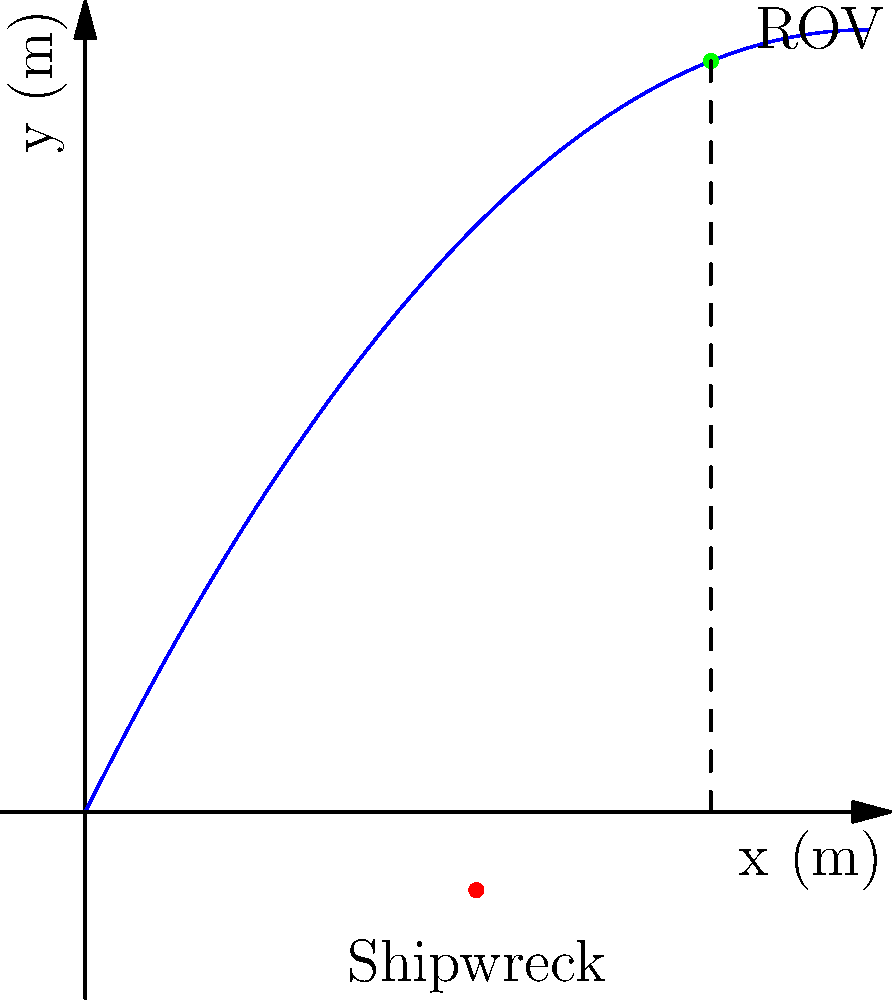An ROV is deployed to investigate a medieval shipwreck site. The ROV's trajectory follows the parabolic path given by the equation $y = -0.02x^2 + 2x$, where $x$ and $y$ are measured in meters. The shipwreck is located at coordinates (25, -5). At what horizontal distance from its starting point will the ROV be directly above the shipwreck? To solve this problem, we need to follow these steps:

1) The ROV will be directly above the shipwreck when its x-coordinate matches that of the shipwreck, which is 25 meters.

2) We need to find the y-coordinate of the ROV when x = 25. We can do this by plugging x = 25 into the equation of the ROV's path:

   $y = -0.02x^2 + 2x$
   $y = -0.02(25)^2 + 2(25)$
   $y = -0.02(625) + 50$
   $y = -12.5 + 50 = 37.5$

3) So, when the ROV is directly above the shipwreck, its coordinates are (25, 37.5).

4) The question asks for the horizontal distance from the starting point. The starting point of the ROV is at x = 0, so the horizontal distance is simply the x-coordinate of the point we found: 25 meters.
Answer: 25 meters 